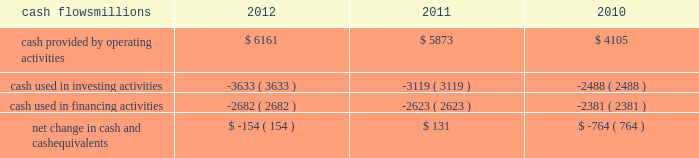At december 31 , 2012 and 2011 , we had a working capital surplus .
This reflects a strong cash position , which provides enhanced liquidity in an uncertain economic environment .
In addition , we believe we have adequate access to capital markets to meet any foreseeable cash requirements , and we have sufficient financial capacity to satisfy our current liabilities .
Cash flows millions 2012 2011 2010 .
Operating activities higher net income in 2012 increased cash provided by operating activities compared to 2011 , partially offset by lower tax benefits from bonus depreciation ( as explained below ) and payments for past wages based on national labor negotiations settled earlier this year .
Higher net income and lower cash income tax payments in 2011 increased cash provided by operating activities compared to 2010 .
The tax relief , unemployment insurance reauthorization , and job creation act of 2010 provided for 100% ( 100 % ) bonus depreciation for qualified investments made during 2011 , and 50% ( 50 % ) bonus depreciation for qualified investments made during 2012 .
As a result of the act , the company deferred a substantial portion of its 2011 income tax expense .
This deferral decreased 2011 income tax payments , thereby contributing to the positive operating cash flow .
In future years , however , additional cash will be used to pay income taxes that were previously deferred .
In addition , the adoption of a new accounting standard in january of 2010 changed the accounting treatment for our receivables securitization facility from a sale of undivided interests ( recorded as an operating activity ) to a secured borrowing ( recorded as a financing activity ) , which decreased cash provided by operating activities by $ 400 million in 2010 .
Investing activities higher capital investments in 2012 drove the increase in cash used in investing activities compared to 2011 .
Included in capital investments in 2012 was $ 75 million for the early buyout of 165 locomotives under long-term operating and capital leases during the first quarter of 2012 , which we exercised due to favorable economic terms and market conditions .
Higher capital investments partially offset by higher proceeds from asset sales in 2011 drove the increase in cash used in investing activities compared to 2010. .
What would 2012 capital expenditures have been without the early buyout of locomotives , in millions? 
Computations: (3633 - 75)
Answer: 3558.0. 